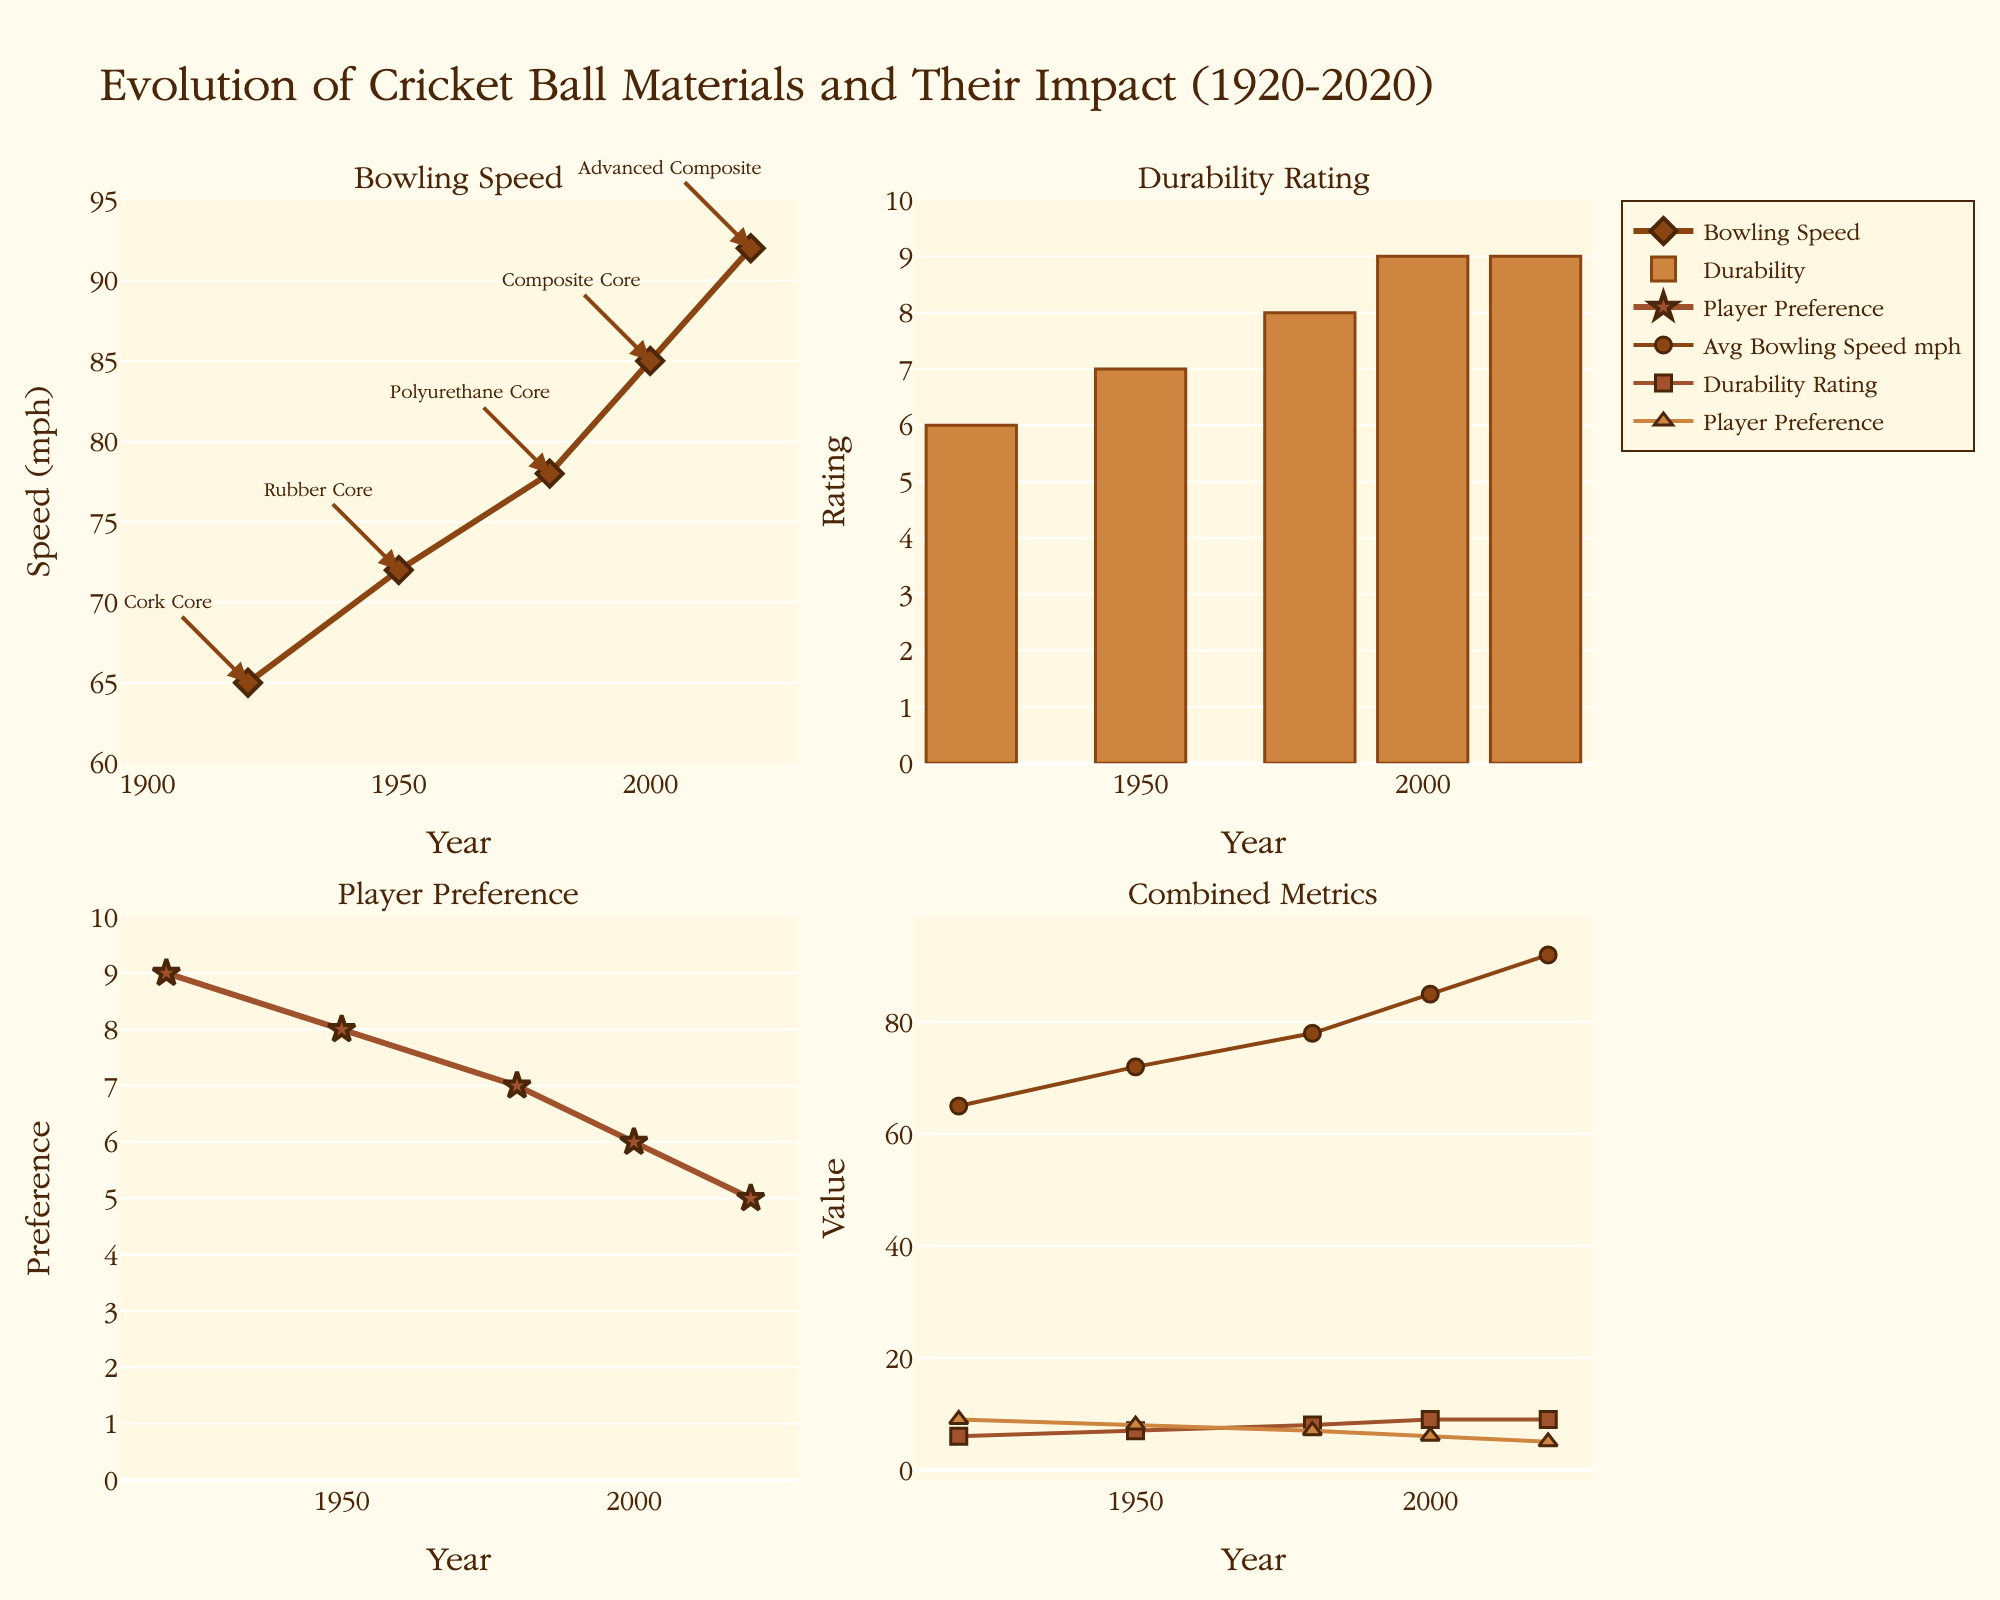What is the title of the figure? The title is located at the top of the figure.
Answer: Evolution of Cricket Ball Materials and Their Impact (1920-2020) What years are covered in the figure? Look at the x-axis for the plots; it starts from 1920 and ends at 2020.
Answer: 1920-2020 Which year has the highest average bowling speed? Refer to the first subplot on the top left titled "Bowling Speed." The highest point on the line is at 2020.
Answer: 2020 What was the average bowling speed in 1950? Check the data point on the first subplot for the year 1950.
Answer: 72 mph How has the durability rating changed from 1920 to 2020? Compare the bars in the second subplot from 1920 to 2020; each bar height corresponds to the durability rating. It increases from 6 to 9.
Answer: Increased Which bowling ball type was preferred by players the most? Look at the third subplot "Player Preference" and find the highest point. It's in 1920 for Cork Core with 9.
Answer: Cork Core By how much did the average bowling speed increase from 1920 to 1980? Find the difference between average speeds in 1920 (65 mph) and 1980 (78 mph) using the first subplot. 78 - 65 = 13
Answer: 13 mph Which year had the lowest player preference rating? Refer to the third subplot; the lowest point is in 2020.
Answer: 2020 In the combined metrics subplot, which metric shows the smallest increase over the century? Compare the slopes of the lines: Avg Bowling Speed, Durability Rating, and Player Preference. Player Preference has the smallest increase.
Answer: Player Preference How did the average bowling speed change from 1950 to 2000? Check the line in the first subplot from 1950 (72 mph) to 2000 (85 mph). The values went up.
Answer: Increased 